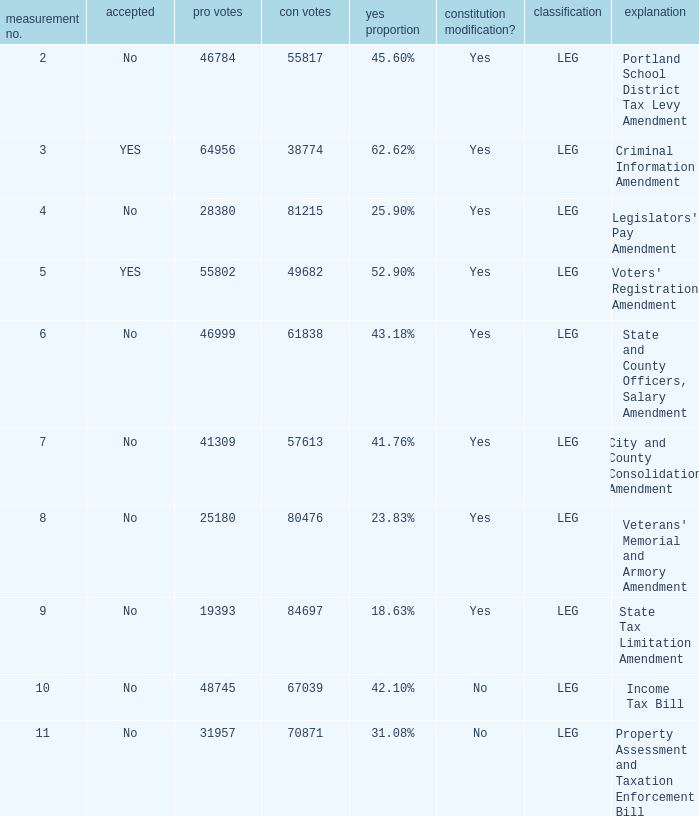HOw many no votes were there when there were 45.60% yes votes 55817.0. 